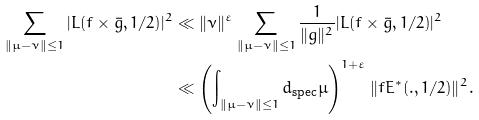Convert formula to latex. <formula><loc_0><loc_0><loc_500><loc_500>\sum _ { \| \mu - \nu \| \leq 1 } | L ( f \times \bar { g } , 1 / 2 ) | ^ { 2 } & \ll \| \nu \| ^ { \varepsilon } \sum _ { \| \mu - \nu \| \leq 1 } \frac { 1 } { \| g \| ^ { 2 } } | L ( f \times \bar { g } , 1 / 2 ) | ^ { 2 } \\ & \ll \left ( \int _ { \| \mu - \nu \| \leq 1 } d _ { \text {spec} } \mu \right ) ^ { 1 + \varepsilon } \| f E ^ { \ast } ( . , 1 / 2 ) \| ^ { 2 } .</formula> 